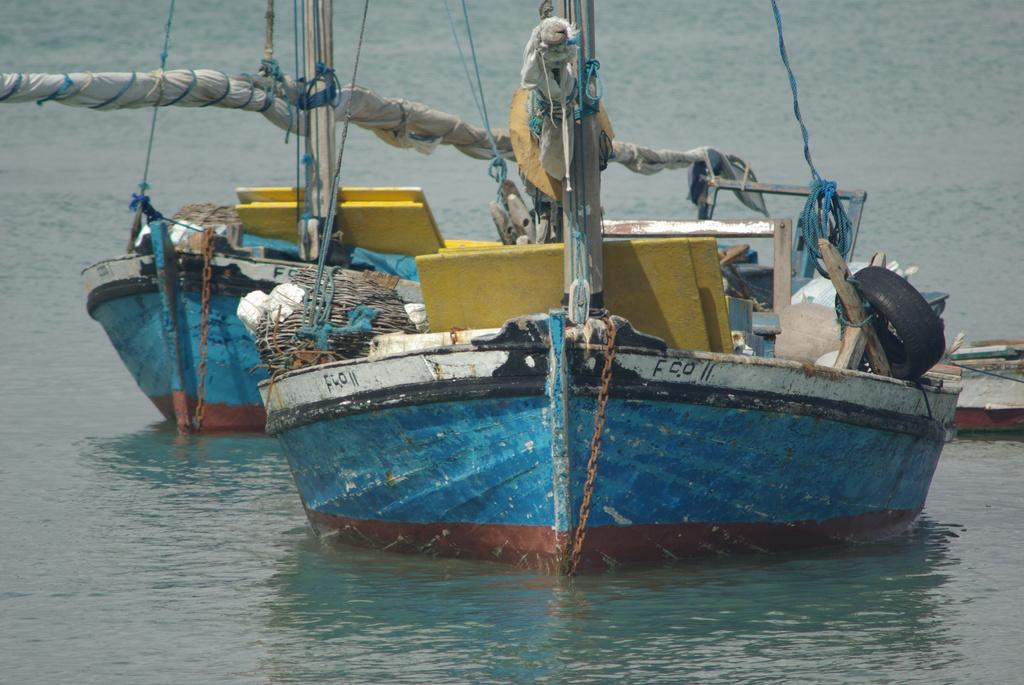What can be seen in the image? There are boats in the image. How are the boats situated in the image? The boats are floating on the water. What type of sound can be heard coming from the boats in the image? There is no sound present in the image, as it is a still image. What emotion might the people in the boats be experiencing in the image? The image does not provide any information about the emotions of the people in the boats, if any are present. 